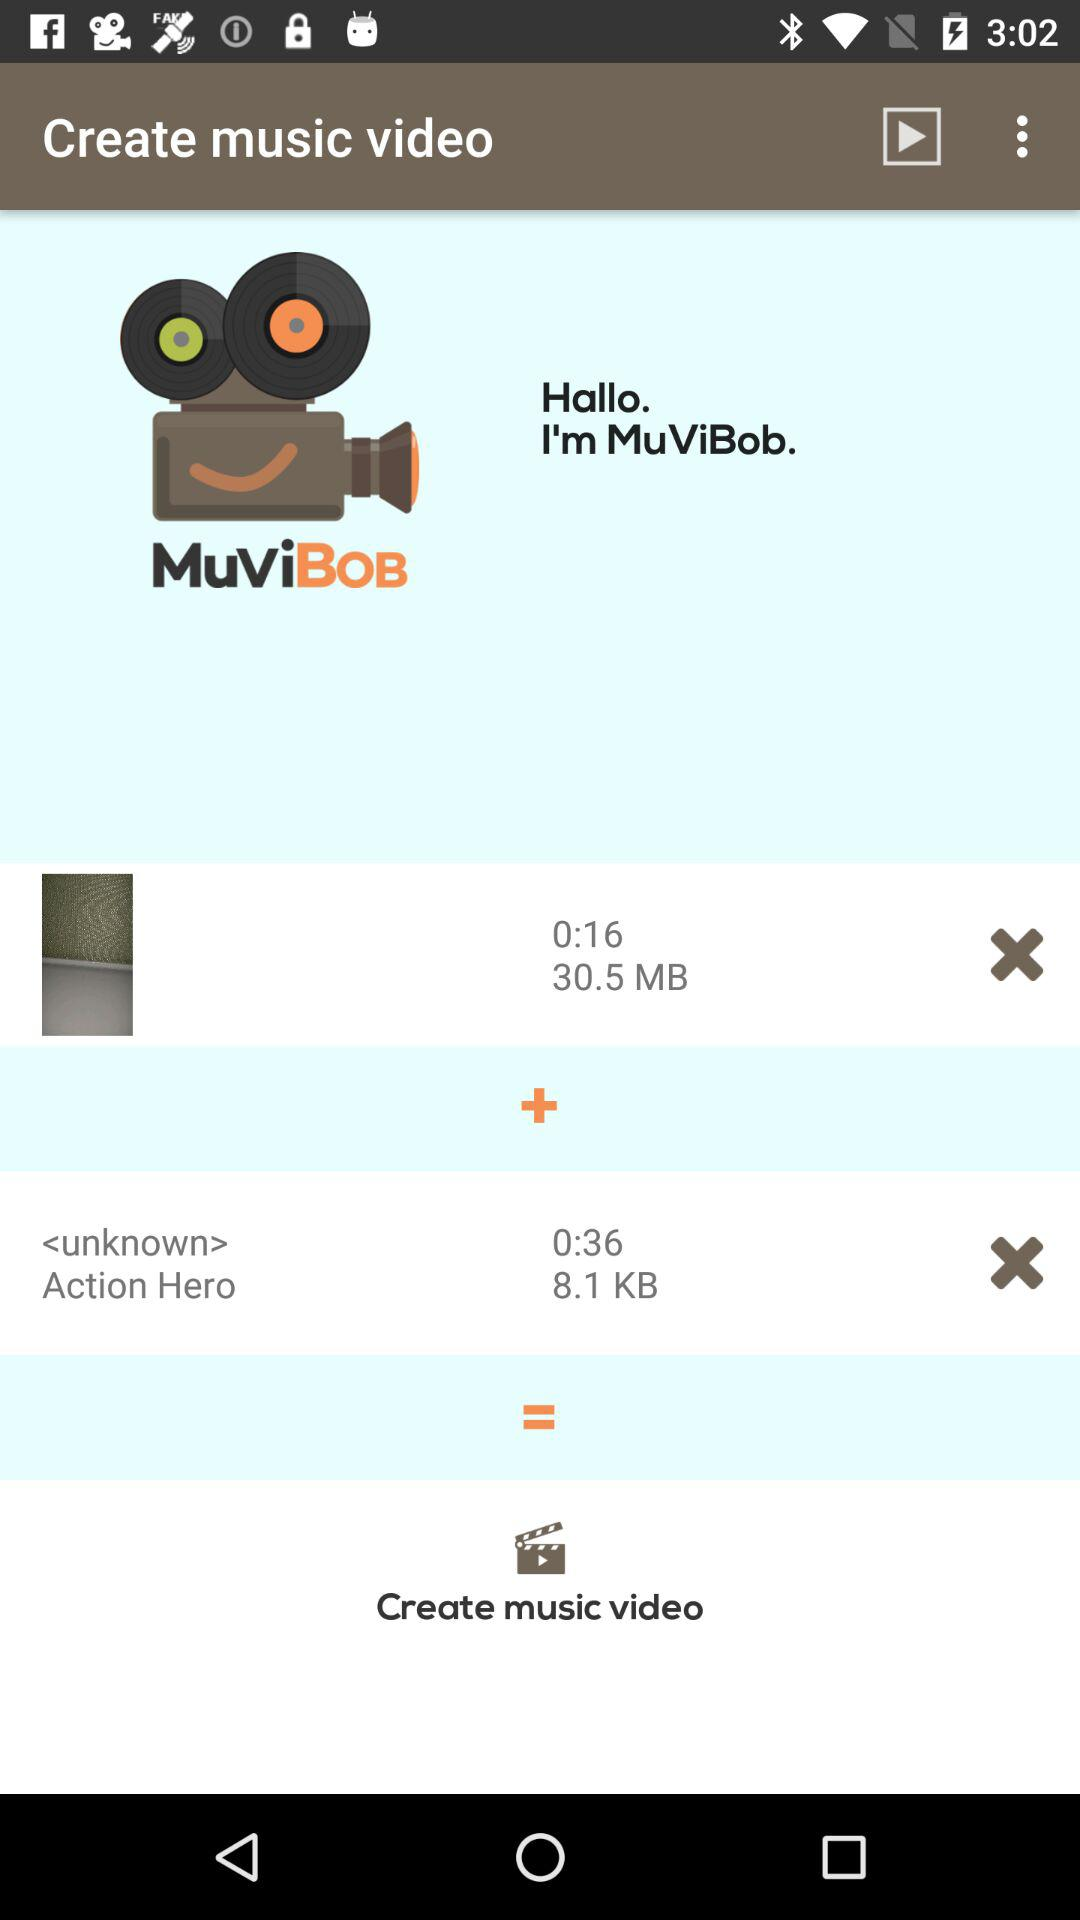How much longer is the second video than the first video?
Answer the question using a single word or phrase. 0:20 